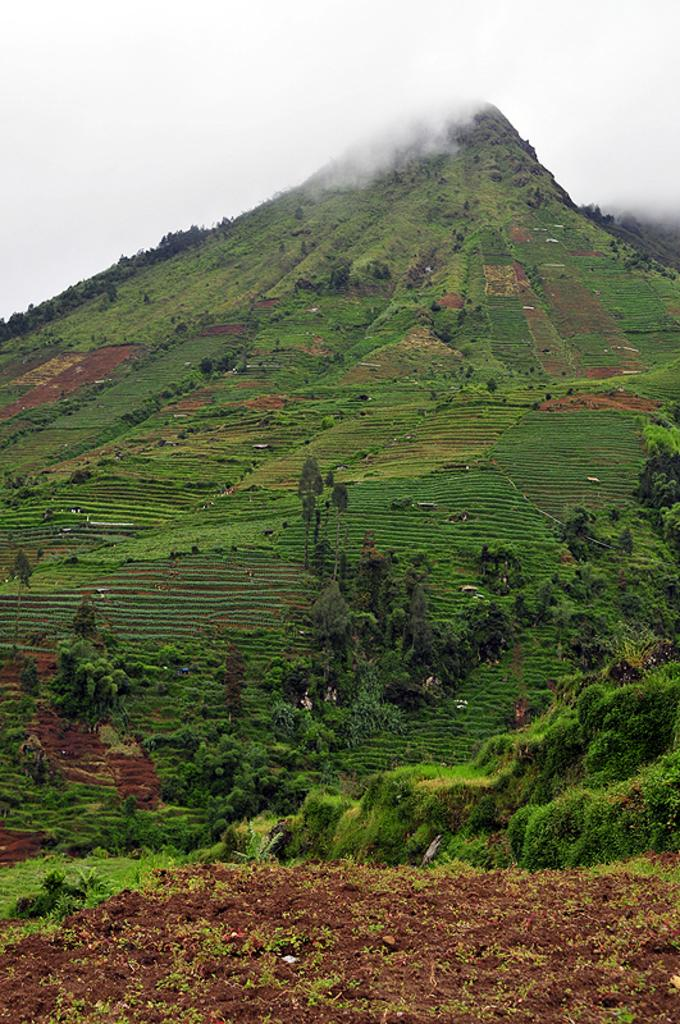What type of landscape feature is present in the image? There is a hill in the image. What can be found on the hill? The hill includes greenery, plants, and sand. How many rabbits are hopping around on the hill in the image? There are no rabbits present in the image; it only features a hill with greenery, plants, and sand. 